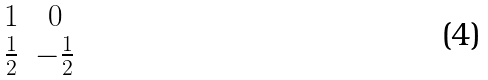<formula> <loc_0><loc_0><loc_500><loc_500>\begin{array} { c c } 1 & 0 \\ \frac { 1 } { 2 } & - \frac { 1 } { 2 } \end{array}</formula> 